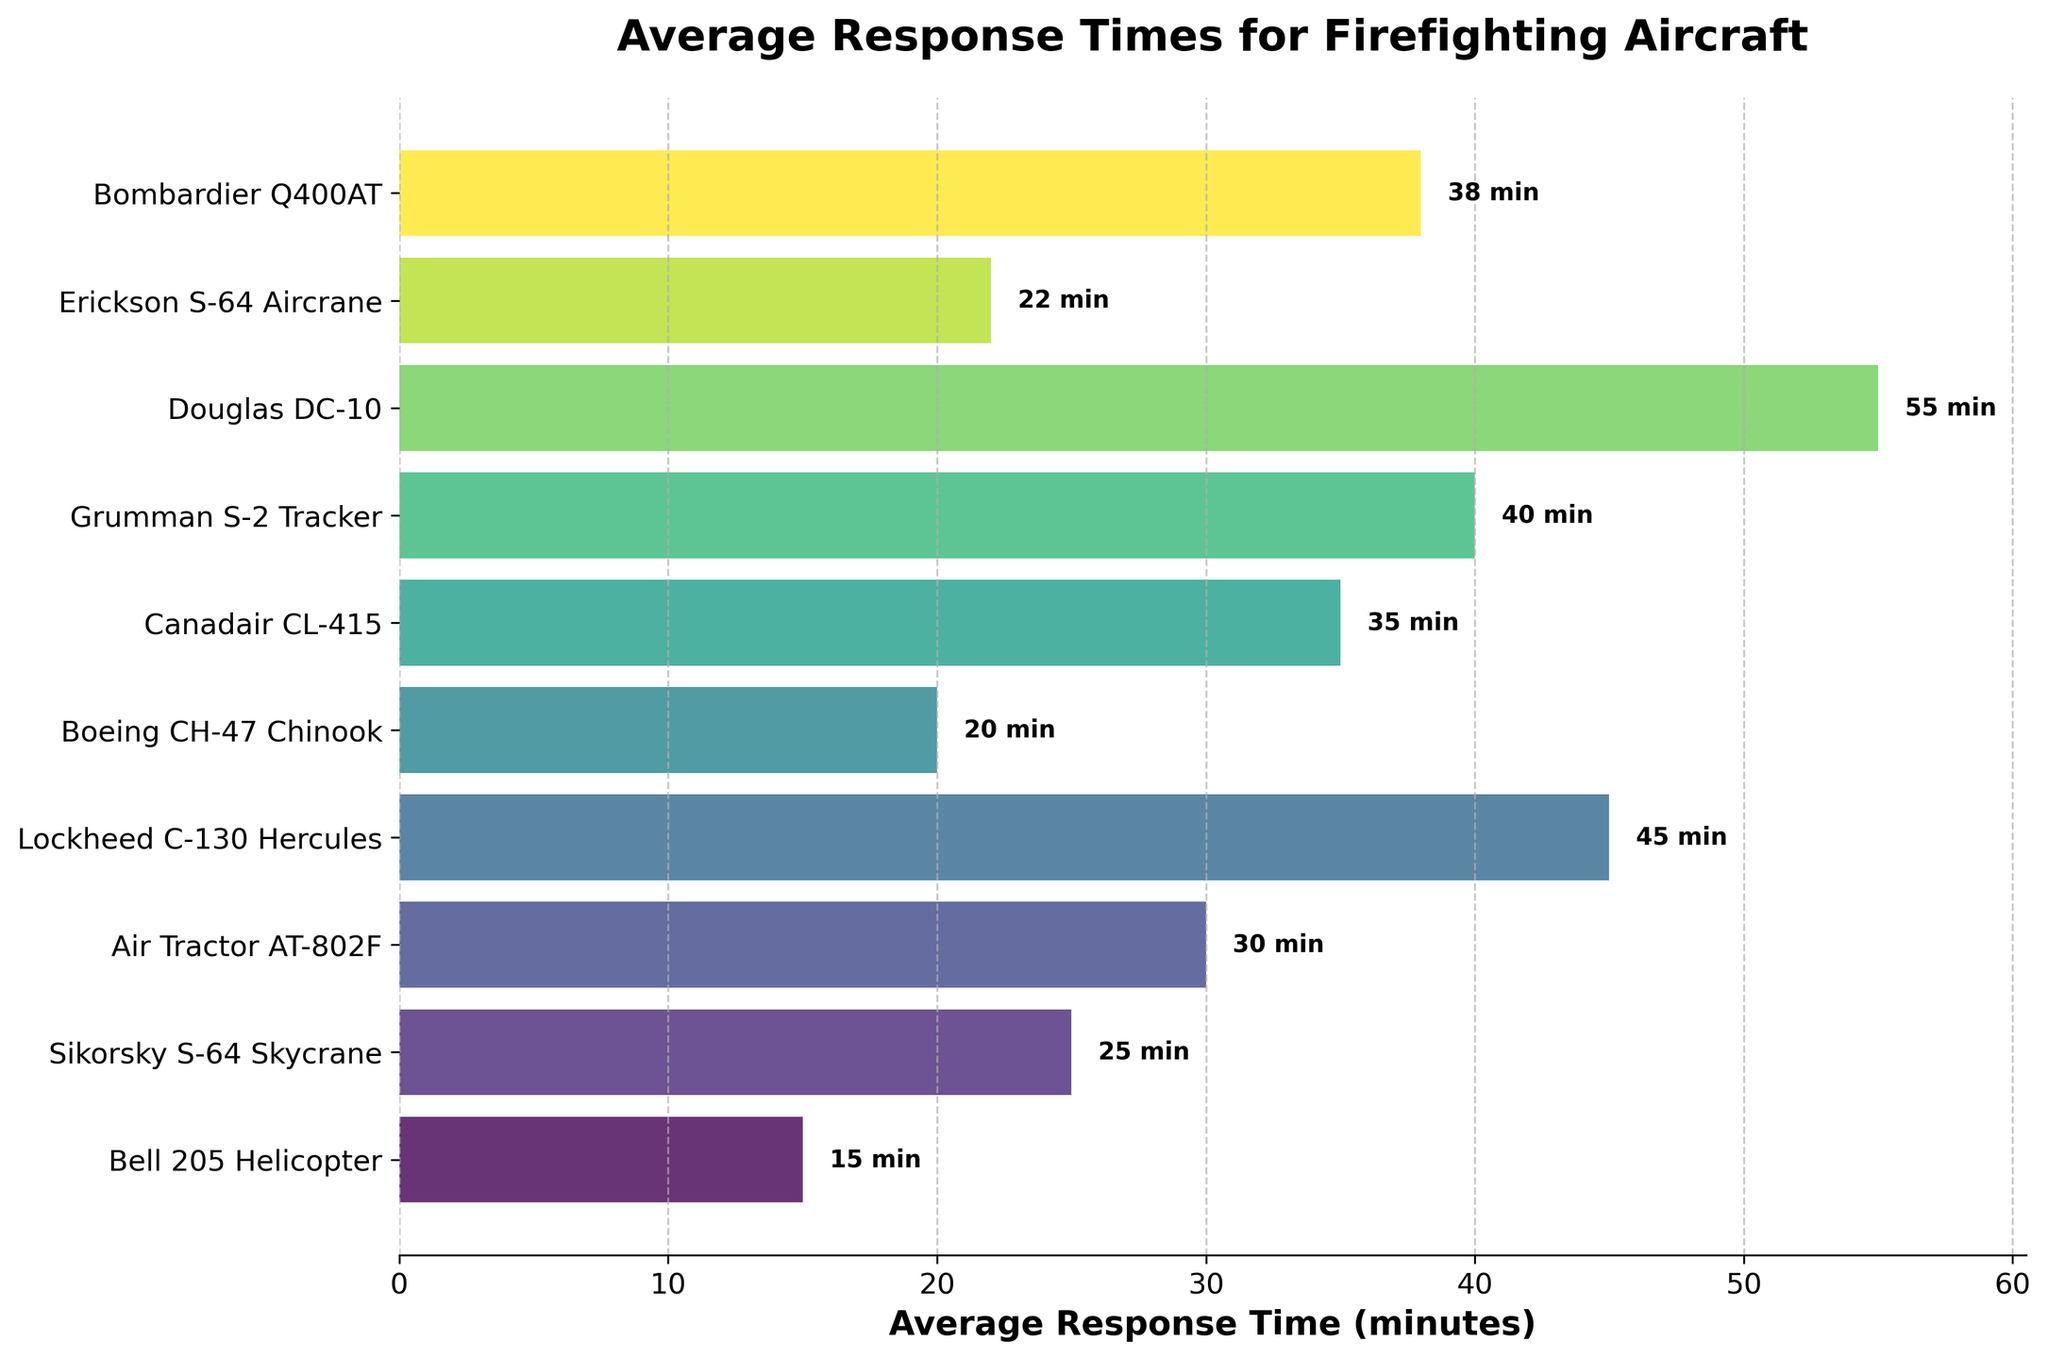Which aircraft type has the shortest average response time? The aircraft with the shortest bar on the chart represents the shortest average response time. The Bell 205 Helicopter has the shortest bar indicating 15 minutes.
Answer: Bell 205 Helicopter Which aircraft type has the longest average response time? The aircraft with the longest bar on the chart represents the longest average response time. The Douglas DC-10 has the longest bar indicating 55 minutes.
Answer: Douglas DC-10 How much longer does the Grumman S-2 Tracker take to respond compared to the Bell 205 Helicopter? Find the difference between the average response times of the Grumman S-2 Tracker and the Bell 205 Helicopter. Grumman S-2 Tracker takes 40 minutes, and Bell 205 Helicopter takes 15 minutes, so the difference is 40 - 15 = 25 minutes.
Answer: 25 minutes What is the combined average response time of the Erickson S-64 Aircrane and Sikorsky S-64 Skycrane? Sum the average response times of both aircraft types. Erickson S-64 Aircrane takes 22 minutes, and Sikorsky S-64 Skycrane takes 25 minutes, so their combined time is 22 + 25 = 47 minutes.
Answer: 47 minutes Is the average response time of the Canadair CL-415 greater than the Boeing CH-47 Chinook? Compare their average response times: Canadair CL-415 is 35 minutes, and Boeing CH-47 Chinook is 20 minutes. Since 35 is greater than 20, the answer is yes.
Answer: Yes What is the average response time of all the aircraft combined? Sum all the average response times and divide by the number of aircraft types. The total sum is 15 + 25 + 30 + 45 + 20 + 35 + 40 + 55 + 22 + 38 = 325 minutes. There are 10 aircraft types, so the average is 325 / 10 = 32.5 minutes.
Answer: 32.5 minutes How many aircraft have an average response time less than 30 minutes? Count the bars representing aircraft types with average response times below 30 minutes. These are Bell 205 Helicopter (15), Sikorsky S-64 Skycrane (25), Boeing CH-47 Chinook (20), and Erickson S-64 Aircrane (22), totaling 4 aircraft.
Answer: 4 Which aircraft type's average response time is closest to the median response time? First, find the median of the response times by sorting them: 15, 20, 22, 25, 30, 35, 38, 40, 45, 55. The median is the average of the 5th and 6th values: (30 + 35) / 2 = 32.5. The closest average response time is that of the Bombardier Q400AT with 38 minutes.
Answer: Bombardier Q400AT 